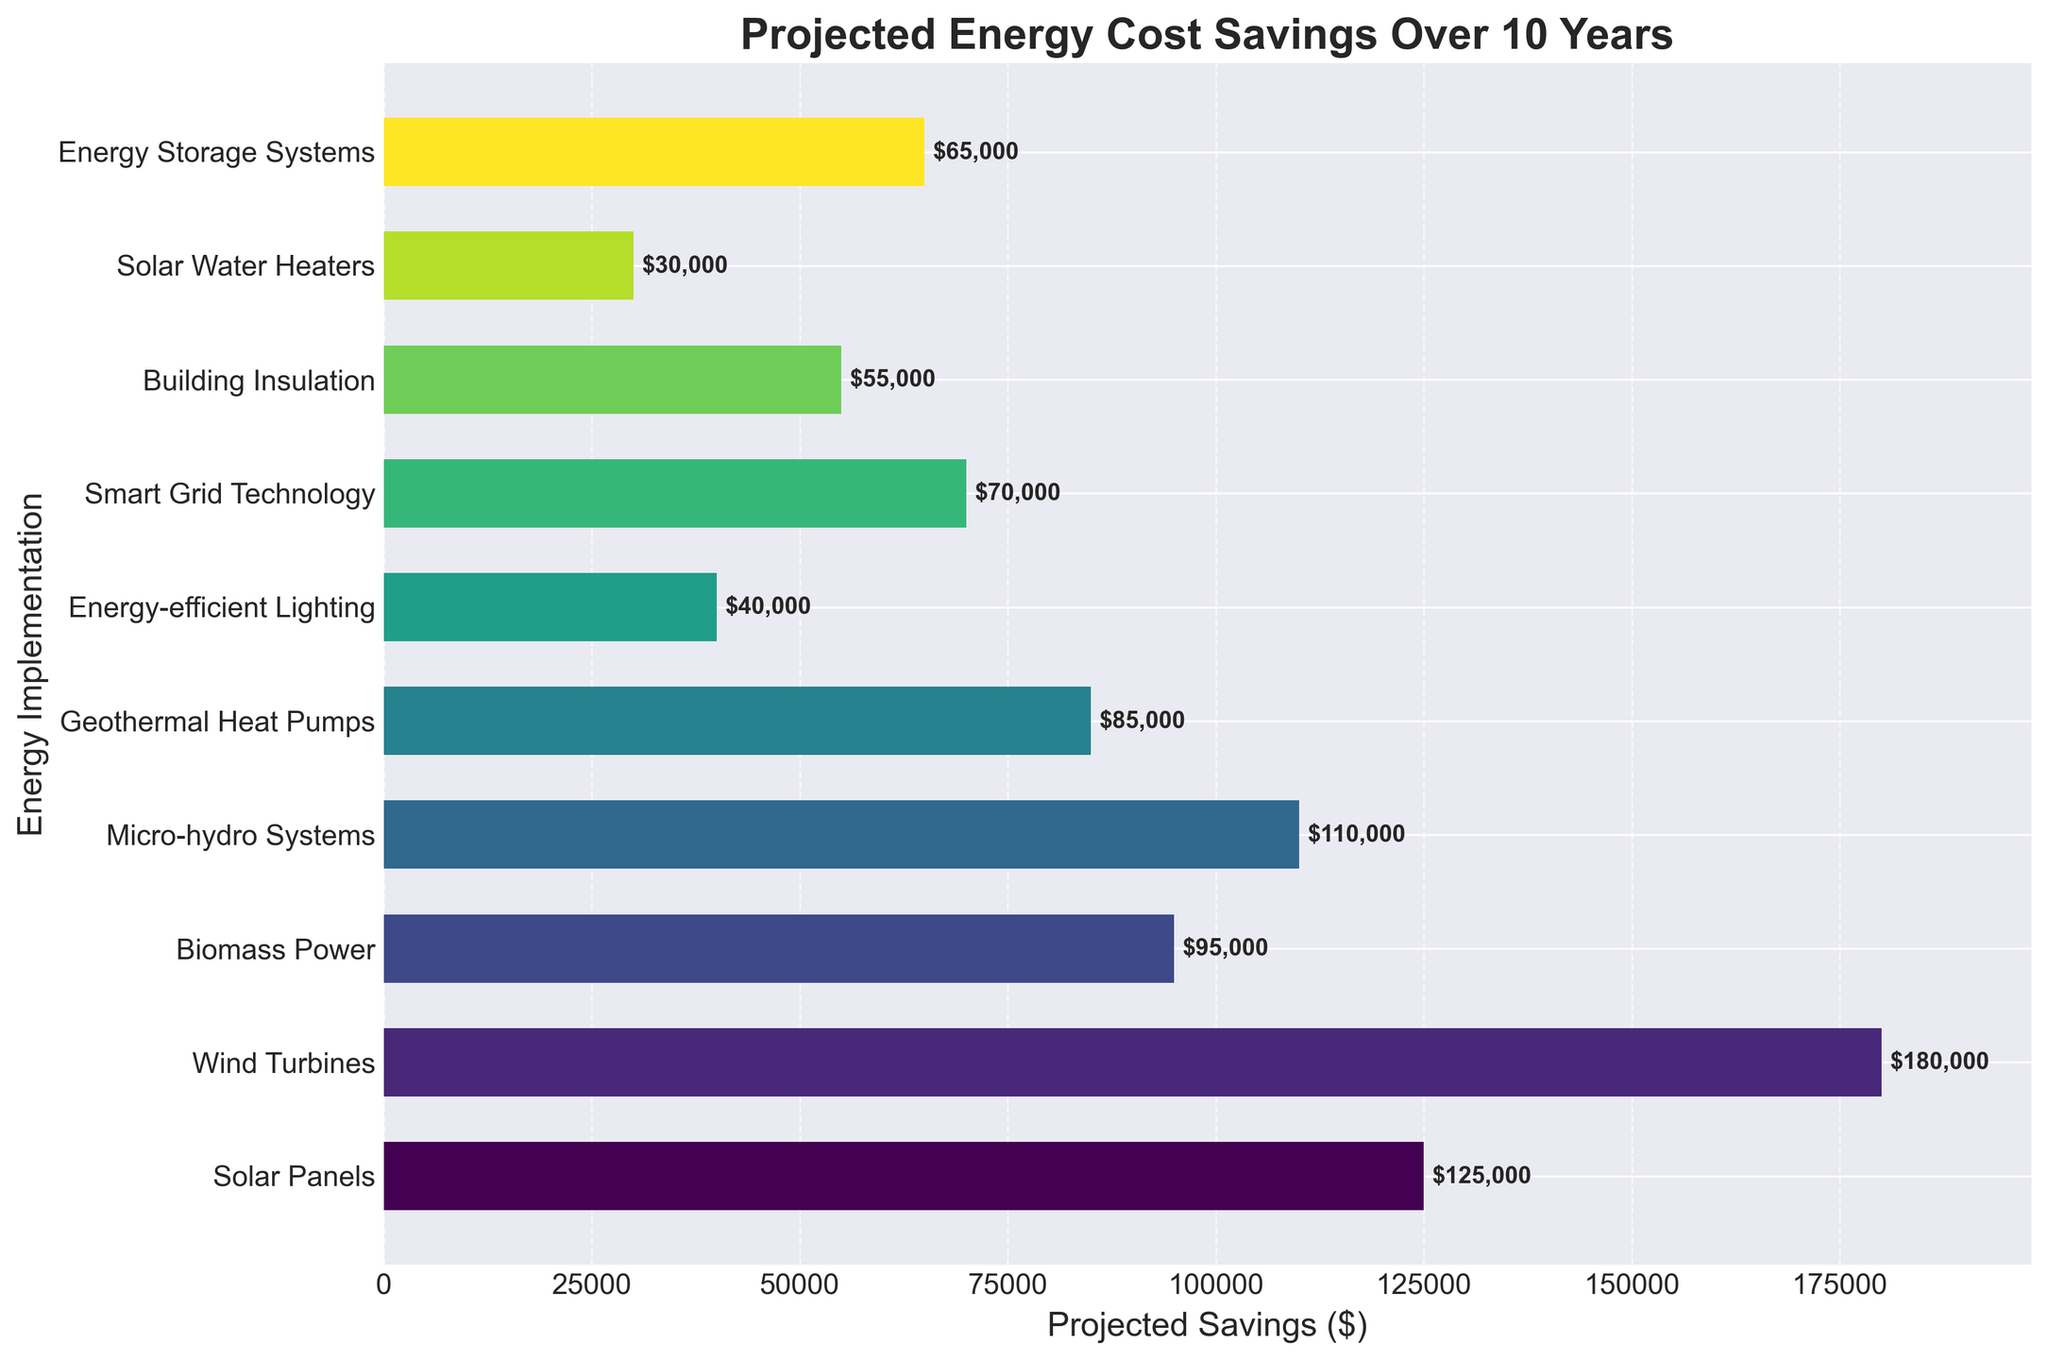Which energy implementation has the highest projected savings? The figure shows various energy implementations and their projected savings. The bar for Wind Turbines extends the furthest to the right, indicating the highest projected savings.
Answer: Wind Turbines How much more projected savings do Wind Turbines have compared to Solar Panels? Find the values for Wind Turbines ($180,000) and Solar Panels ($125,000) from the chart. Then, calculate the difference: $180,000 - $125,000.
Answer: $55,000 Which energy implementation has the lowest projected savings? From the figure, the bar for Solar Water Heaters is the shortest, indicating the lowest projected savings.
Answer: Solar Water Heaters What's the total projected savings for Biomass Power and Smart Grid Technology combined? Locate the bars for Biomass Power ($95,000) and Smart Grid Technology ($70,000). Add the two values together: $95,000 + $70,000.
Answer: $165,000 Which energy implementation has nearly half the projected savings of Wind Turbines? Wind Turbines have $180,000 in projected savings. Half of this is $90,000. The closest implementation is Biomass Power with $95,000.
Answer: Biomass Power What is the average projected savings of the top three energy implementations? Identify the top three (Wind Turbines: $180,000, Solar Panels: $125,000, Micro-hydro Systems: $110,000). Calculate the average: ($180,000 + $125,000 + $110,000) / 3.
Answer: $138,333 Compare the projected savings of Energy-efficient Lighting and Energy Storage Systems. Which one is higher, and by how much? Find the values: Energy-efficient Lighting ($40,000) and Energy Storage Systems ($65,000). Calculate the difference: $65,000 - $40,000.
Answer: Energy Storage Systems by $25,000 What's the combined projected savings of the three implementations with the smallest savings? Identify the smallest three (Solar Water Heaters: $30,000, Energy-efficient Lighting: $40,000, Building Insulation: $55,000). Sum them: $30,000 + $40,000 + $55,000.
Answer: $125,000 How much more projected savings does Geothermal Heat Pumps have over Energy-efficient Lighting? Find the values: Geothermal Heat Pumps ($85,000) and Energy-efficient Lighting ($40,000). Calculate the difference: $85,000 - $40,000.
Answer: $45,000 What is the median projected savings value among all energy implementations? List the values in ascending order: $30,000, $40,000, $55,000, $65,000, $70,000, $85,000, $95,000, $110,000, $125,000, $180,000. The median is the average of the 5th and 6th values: ($70,000 + $85,000) / 2.
Answer: $77,500 